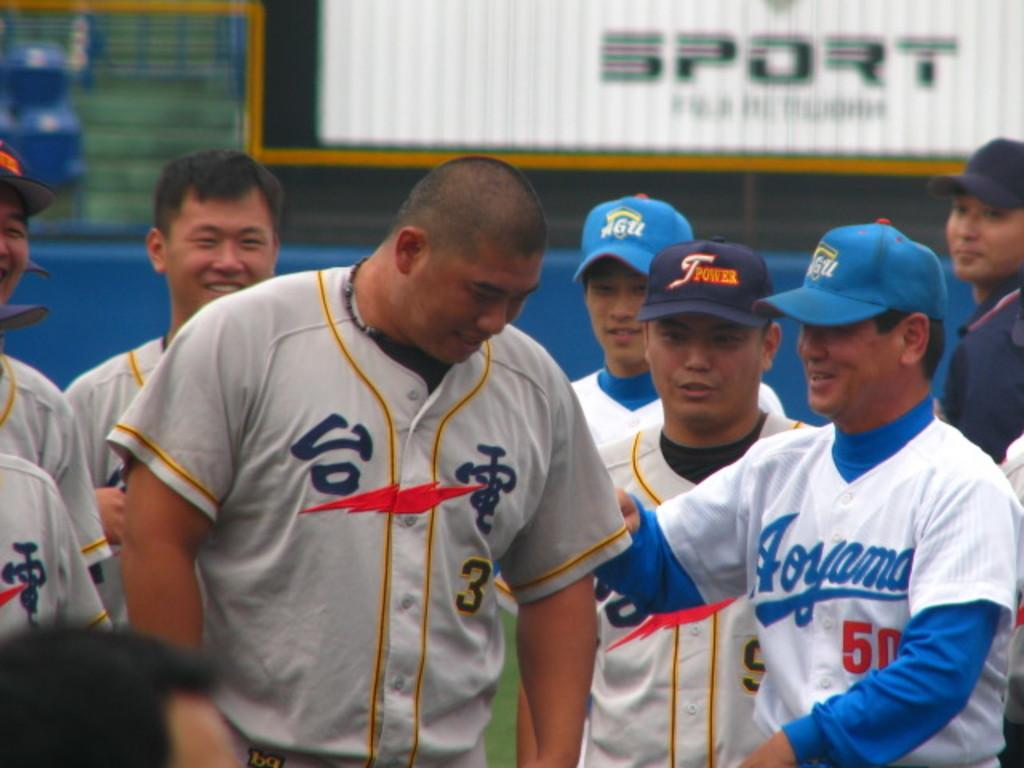<image>
Offer a succinct explanation of the picture presented. Man wearing a jersey with the number 50 greeting another player. 